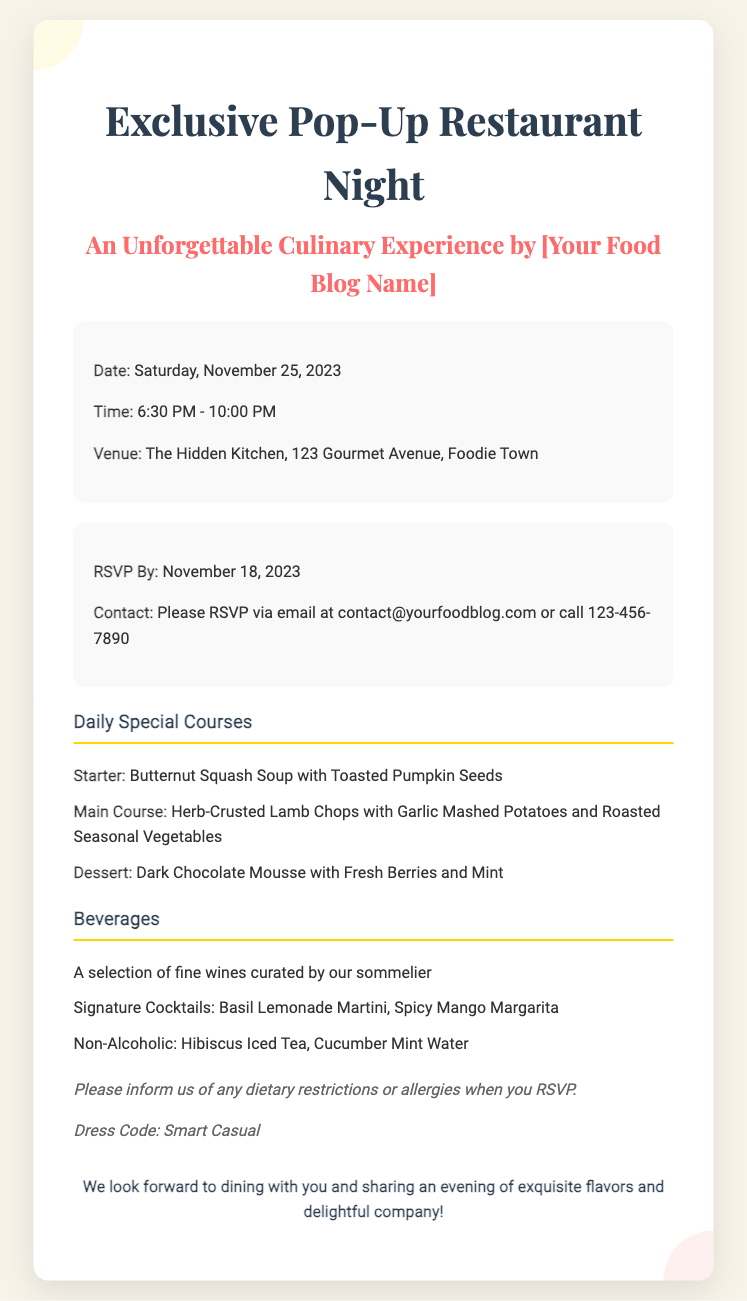What is the date of the event? The date of the event is specified in the document as Saturday, November 25, 2023.
Answer: Saturday, November 25, 2023 What time does the event start? The event details indicate that it starts at 6:30 PM.
Answer: 6:30 PM What is one of the desserts listed? The menu section provides a dessert option which is Dark Chocolate Mousse with Fresh Berries and Mint.
Answer: Dark Chocolate Mousse with Fresh Berries and Mint What should attendees do if they have dietary restrictions? The notes section advises to inform of any dietary restrictions or allergies when RSVPing.
Answer: Inform us of any dietary restrictions or allergies What is the dress code for the event? According to the notes, the dress code is Smart Casual.
Answer: Smart Casual How can attendees RSVP? The RSVP info section specifies that attendees can RSVP via email or phone call.
Answer: Email or call What time does the event end? The event is noted to end at 10:00 PM according to the event details.
Answer: 10:00 PM What is the main course offered? The menu lists Herb-Crusted Lamb Chops with Garlic Mashed Potatoes and Roasted Seasonal Vegetables as a main course.
Answer: Herb-Crusted Lamb Chops with Garlic Mashed Potatoes and Roasted Seasonal Vegetables 